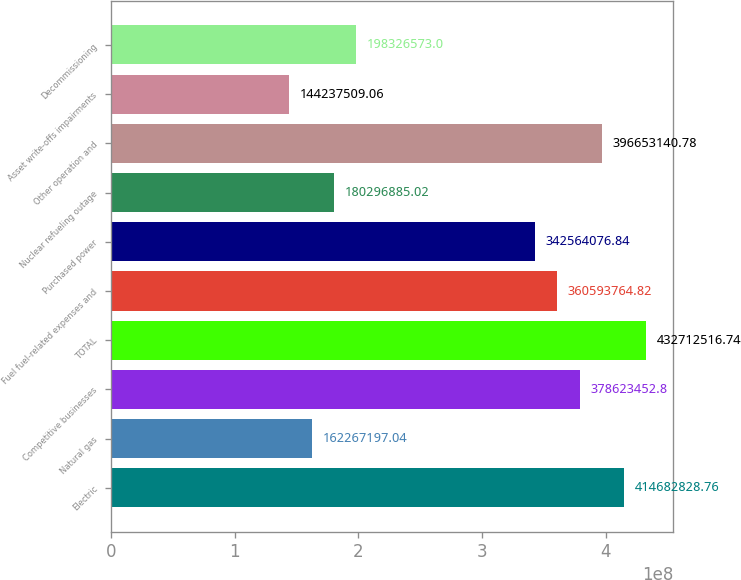Convert chart. <chart><loc_0><loc_0><loc_500><loc_500><bar_chart><fcel>Electric<fcel>Natural gas<fcel>Competitive businesses<fcel>TOTAL<fcel>Fuel fuel-related expenses and<fcel>Purchased power<fcel>Nuclear refueling outage<fcel>Other operation and<fcel>Asset write-offs impairments<fcel>Decommissioning<nl><fcel>4.14683e+08<fcel>1.62267e+08<fcel>3.78623e+08<fcel>4.32713e+08<fcel>3.60594e+08<fcel>3.42564e+08<fcel>1.80297e+08<fcel>3.96653e+08<fcel>1.44238e+08<fcel>1.98327e+08<nl></chart> 